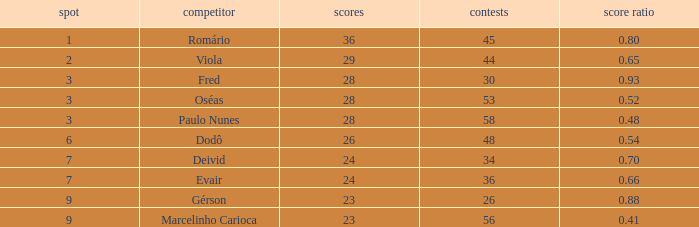How many goals have a goal ration less than 0.8 with 56 games? 1.0. 